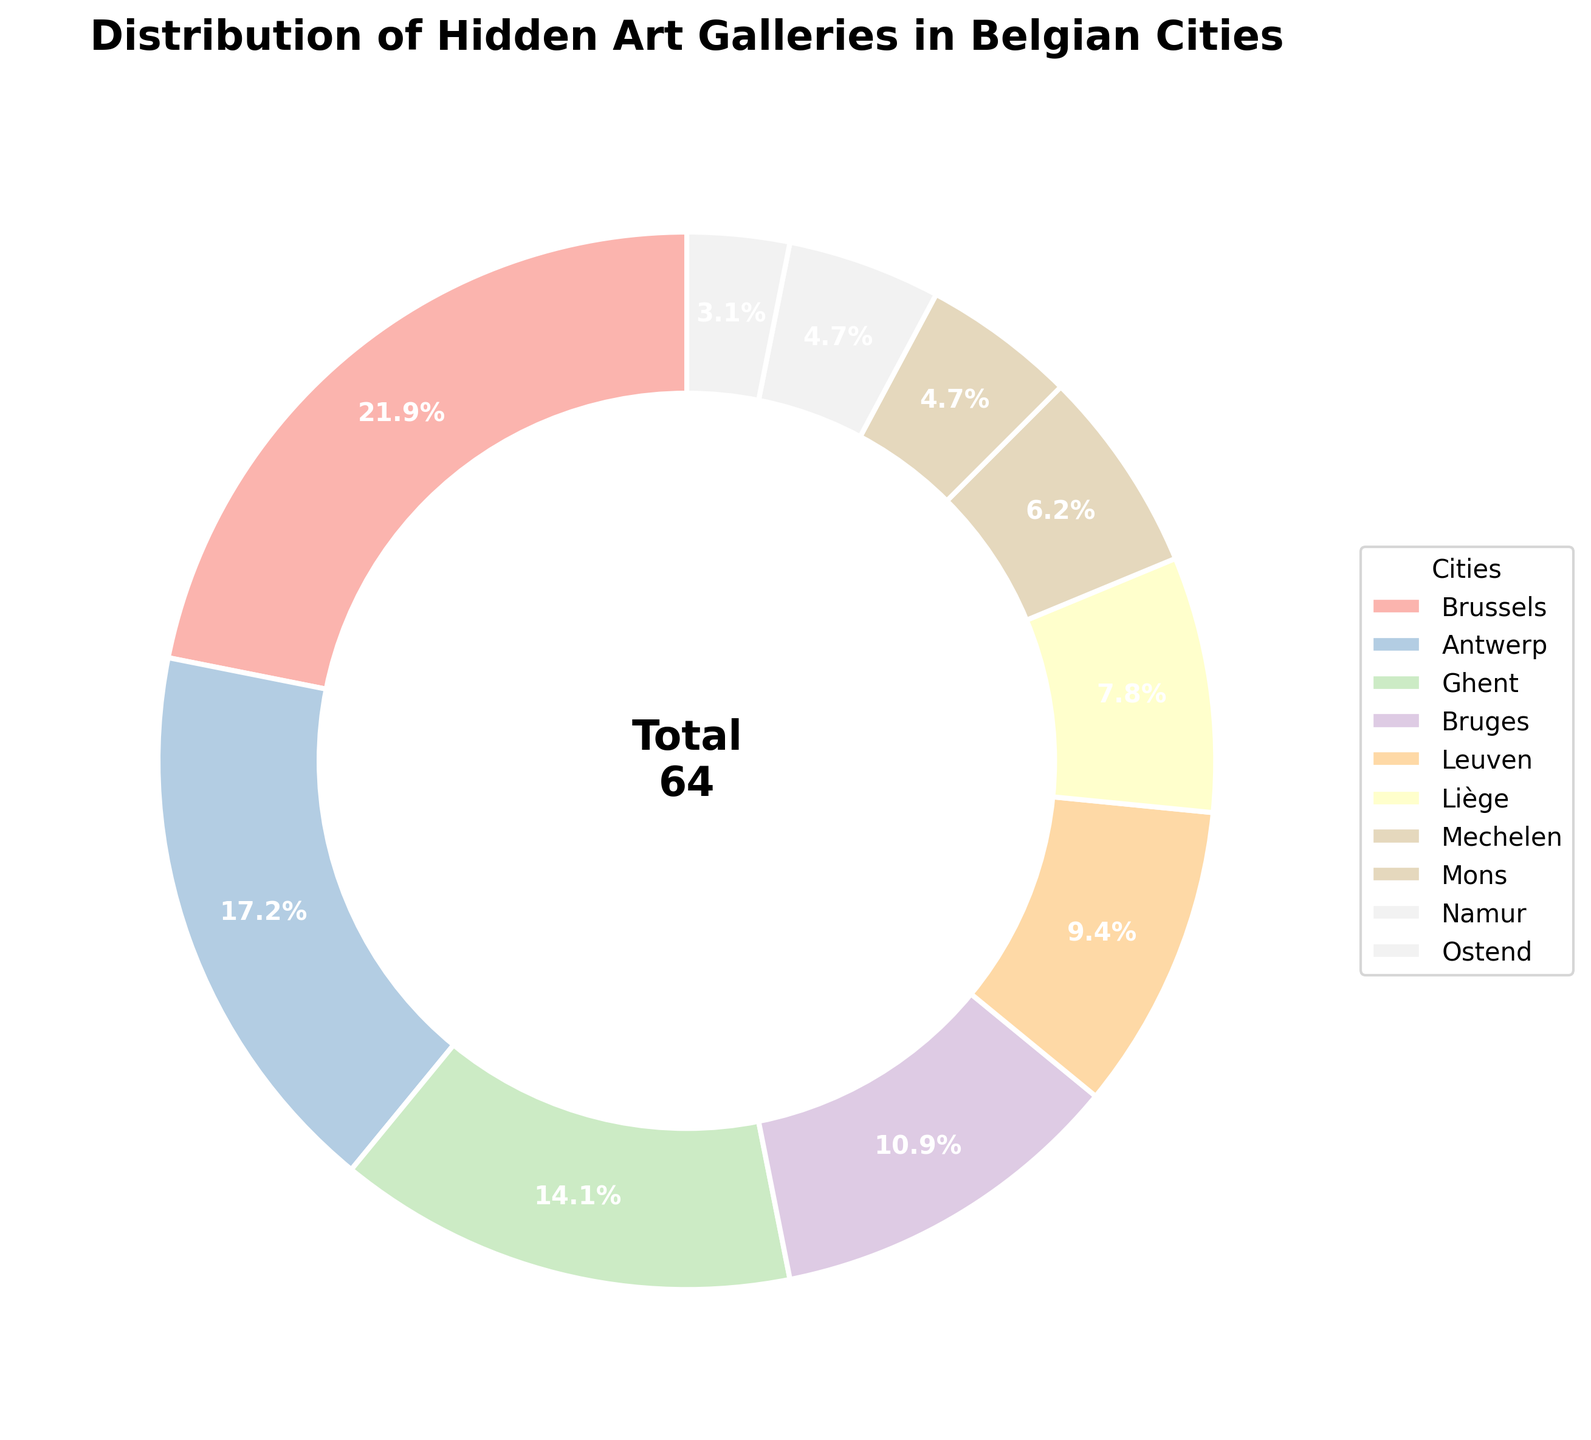What percentage of hidden art galleries are in Brussels? The pie chart shows the percentage distribution of hidden art galleries across Belgian cities. Brussels' percentage is directly given next to its wedge.
Answer: 22.2% Which city has the second-highest number of hidden art galleries? By observing the sizes of wedges and their labels, after Brussels, Antwerp has the second-largest wedge in the pie chart.
Answer: Antwerp What is the total number of hidden art galleries in Ghent and Bruges combined? Find the slices for Ghent and Bruges, note their numbers (Ghent has 9 galleries, Bruges has 7 galleries), and then sum them up.
Answer: 16 How does the number of hidden art galleries in Leuven compare to Liège? Check the wedges for Leuven and Liège. Leuven has 6 galleries, while Liège has 5 galleries. Leuven has one more gallery than Liège.
Answer: Leuven has one more gallery Which city has the smallest share of hidden art galleries in the pie chart? Look for the smallest wedge in the pie chart, which represents Ostend.
Answer: Ostend What is the difference in the number of hidden art galleries between Antwerp and Leuven? Antwerp has 11 galleries, and Leuven has 6 galleries. Subtract the number of galleries in Leuven from those in Antwerp.
Answer: 5 What color represents Namur in the pie chart? Identify Namur by looking at the color next to its label on the pie chart. The color representing Namur is a unique pastel shade.
Answer: (Provide color description) If you combine the hidden art galleries of Mons, Namur, and Ostend, what is the total number? Add the number of galleries for Mons (3), Namur (3), and Ostend (2).
Answer: 8 Which two cities have an equal number of hidden art galleries? Identify the cities with an equal number of galleries by finding wedges with equal values. Namur and Mons both have 3 galleries.
Answer: Namur and Mons What is the percentage share of hidden art galleries in cities other than Brussels? Brussels has 14 galleries. The total number of galleries is 64. Subtract Brussels' galleries from the total and calculate the percentage share for the remaining galleries (50/64 * 100).
Answer: 77.8% 